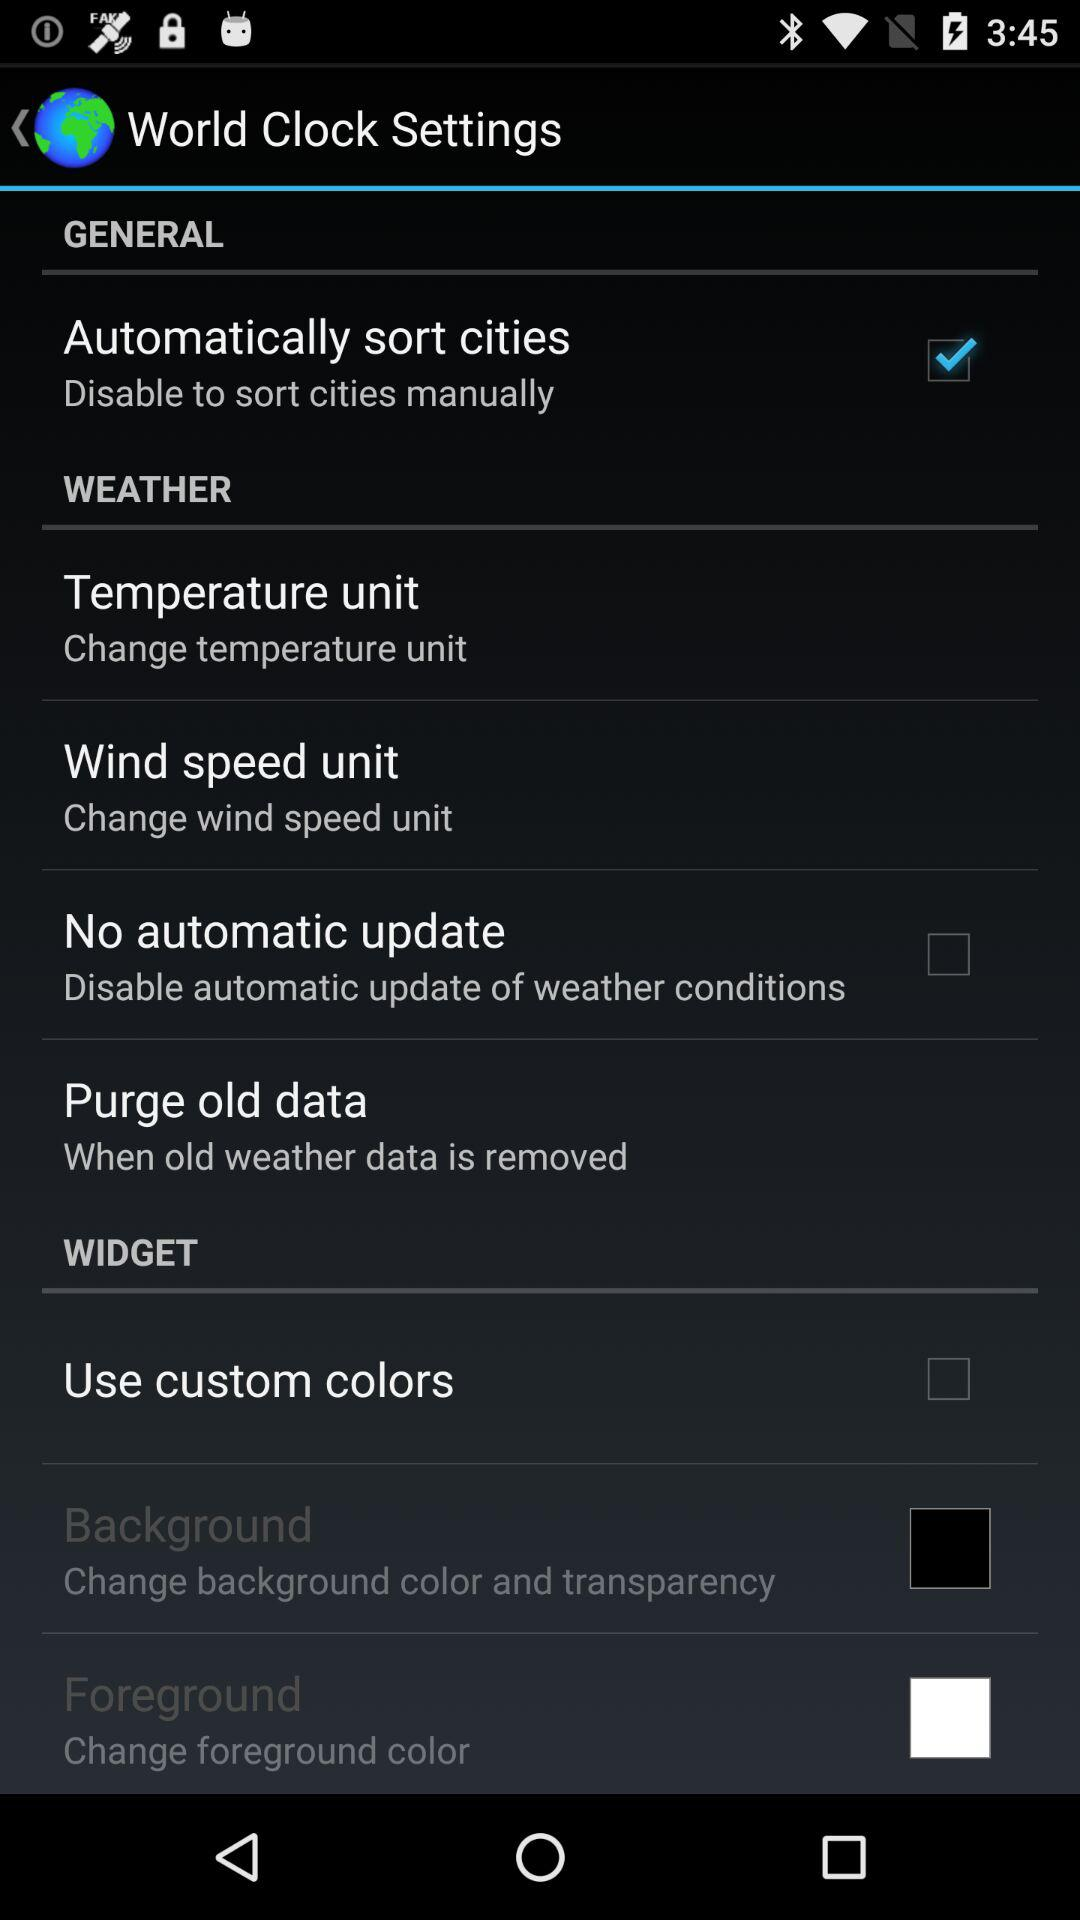When was "World Clock Settings" last updated?
When the provided information is insufficient, respond with <no answer>. <no answer> 